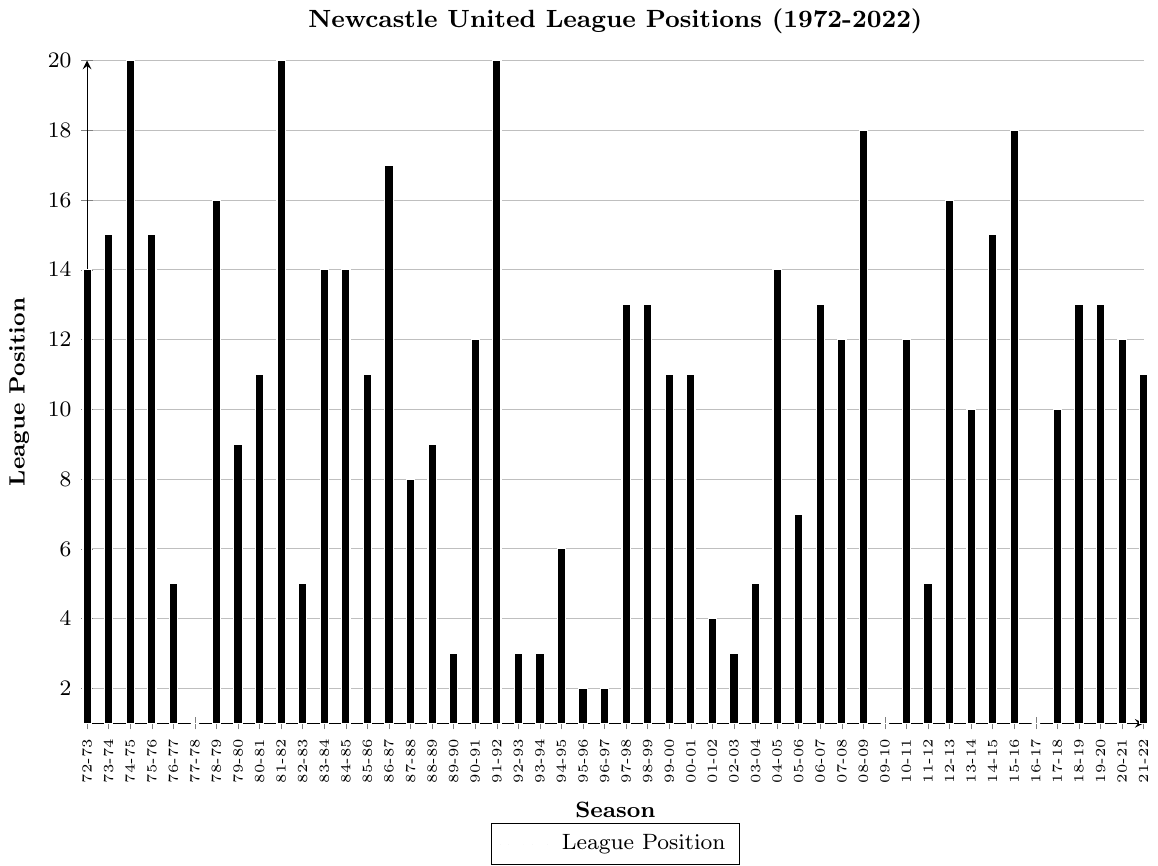What was Newcastle United's league position in the 1995-96 season? Locate the bar corresponding to the 1995-96 season and check its height. The height of the bar indicates the league position.
Answer: 2 What was the best league position Newcastle United achieved between 1972 and 2022? Find the lowest bar in the bar chart, as a lower bar represents a better league position. The lowest bar corresponds to the 1st position, achieved in the 1977-78, 2009-10, and 2016-17 seasons.
Answer: 1 In which seasons did Newcastle United finish in the 3rd position? Identify the bars that have a height corresponding to the 3rd position and note the seasons. The bars for the 1989-90, 1992-93, 1993-94, and 2002-03 seasons are at the 3rd position.
Answer: 1989-90, 1992-93, 1993-94, 2002-03 Compare Newcastle United's league positions in the 1977-78 and 1981-82 seasons. Which one was better? Compare the heights of the bars for the 1977-78 and 1981-82 seasons. The lower the bar, the better the league position. The bar for 1977-78 is lower (indicating 1st position) than the bar for 1981-82 (indicating 20th position).
Answer: 1977-78 How did Newcastle United's league position in the 2015-16 season compare to the 2016-17 season? Compare the heights of the bars for the 2015-16 and 2016-17 seasons. The bar for 2015-16 is higher (indicating 18th position) than the bar for 2016-17 (indicating 1st position).
Answer: 2015-16 was worse What is the average league position of Newcastle United during the 1990s (1990-91 to 1999-00 seasons)? Sum the league positions from the 1990-91 to 1999-00 seasons and then divide by the number of seasons. The positions are 12, 20, 3, 3, 6, 2, 2, 13, 13, 11. The average is (12 + 20 + 3 + 3 + 6 + 2 + 2 + 13 + 13 + 11) / 10 = 8.5.
Answer: 8.5 During which season did Newcastle United finish in the 5th position the most times? Count the number of times the bar reaches the height corresponding to the 5th position, identifying the seasons. Newcastle United finished 5th in the 1976-77, 1982-83, 2003-04, and 2011-12 seasons, so four times.
Answer: 4 seasons Compare the league positions in the 1976-77 and 2001-02 seasons, and state which one was better. Compare the heights of the bars for the 1976-77 and 2001-02 seasons. The lower the bar, the better the league position. The bar for 2001-02 (4th position) is lower than the bar for 1976-77 (5th position).
Answer: 2001-02 How many seasons did Newcastle United finish in the 1st position? Count the number of bars that reach the height corresponding to the 1st position. Newcastle United finished 1st in the 1977-78, 2009-10, and 2016-17 seasons. So, there are three seasons.
Answer: 3 What was Newcastle United's league position in the season immediately following their 1995-96 runner-up finish? Look at the bar for the 1996-97 season which follows the 1995-96 season. Identify its height; it shows the league position. The 1996-97 bar indicates the 2nd position again.
Answer: 2 